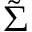<formula> <loc_0><loc_0><loc_500><loc_500>\tilde { \Sigma }</formula> 